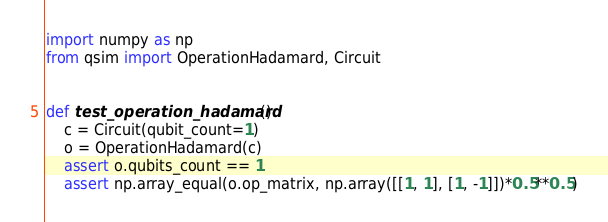<code> <loc_0><loc_0><loc_500><loc_500><_Python_>import numpy as np
from qsim import OperationHadamard, Circuit


def test_operation_hadamard():
    c = Circuit(qubit_count=1)
    o = OperationHadamard(c)
    assert o.qubits_count == 1
    assert np.array_equal(o.op_matrix, np.array([[1, 1], [1, -1]])*0.5**0.5)
</code> 